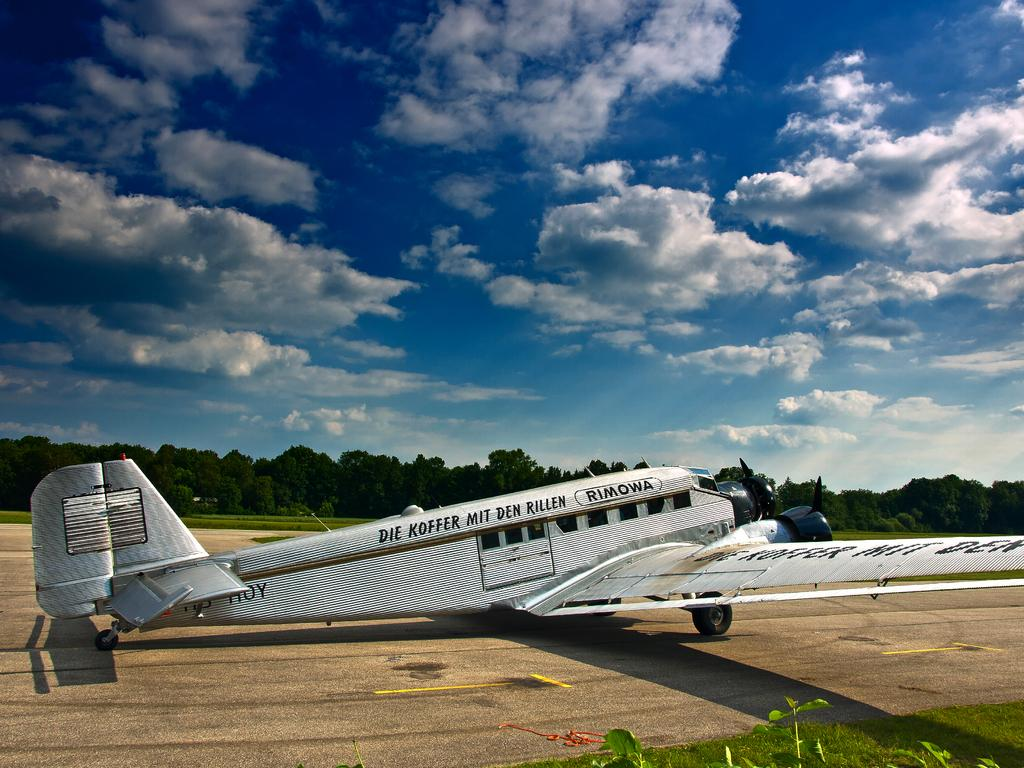Provide a one-sentence caption for the provided image. The vintage Rimowa plane is parked on the runway. 